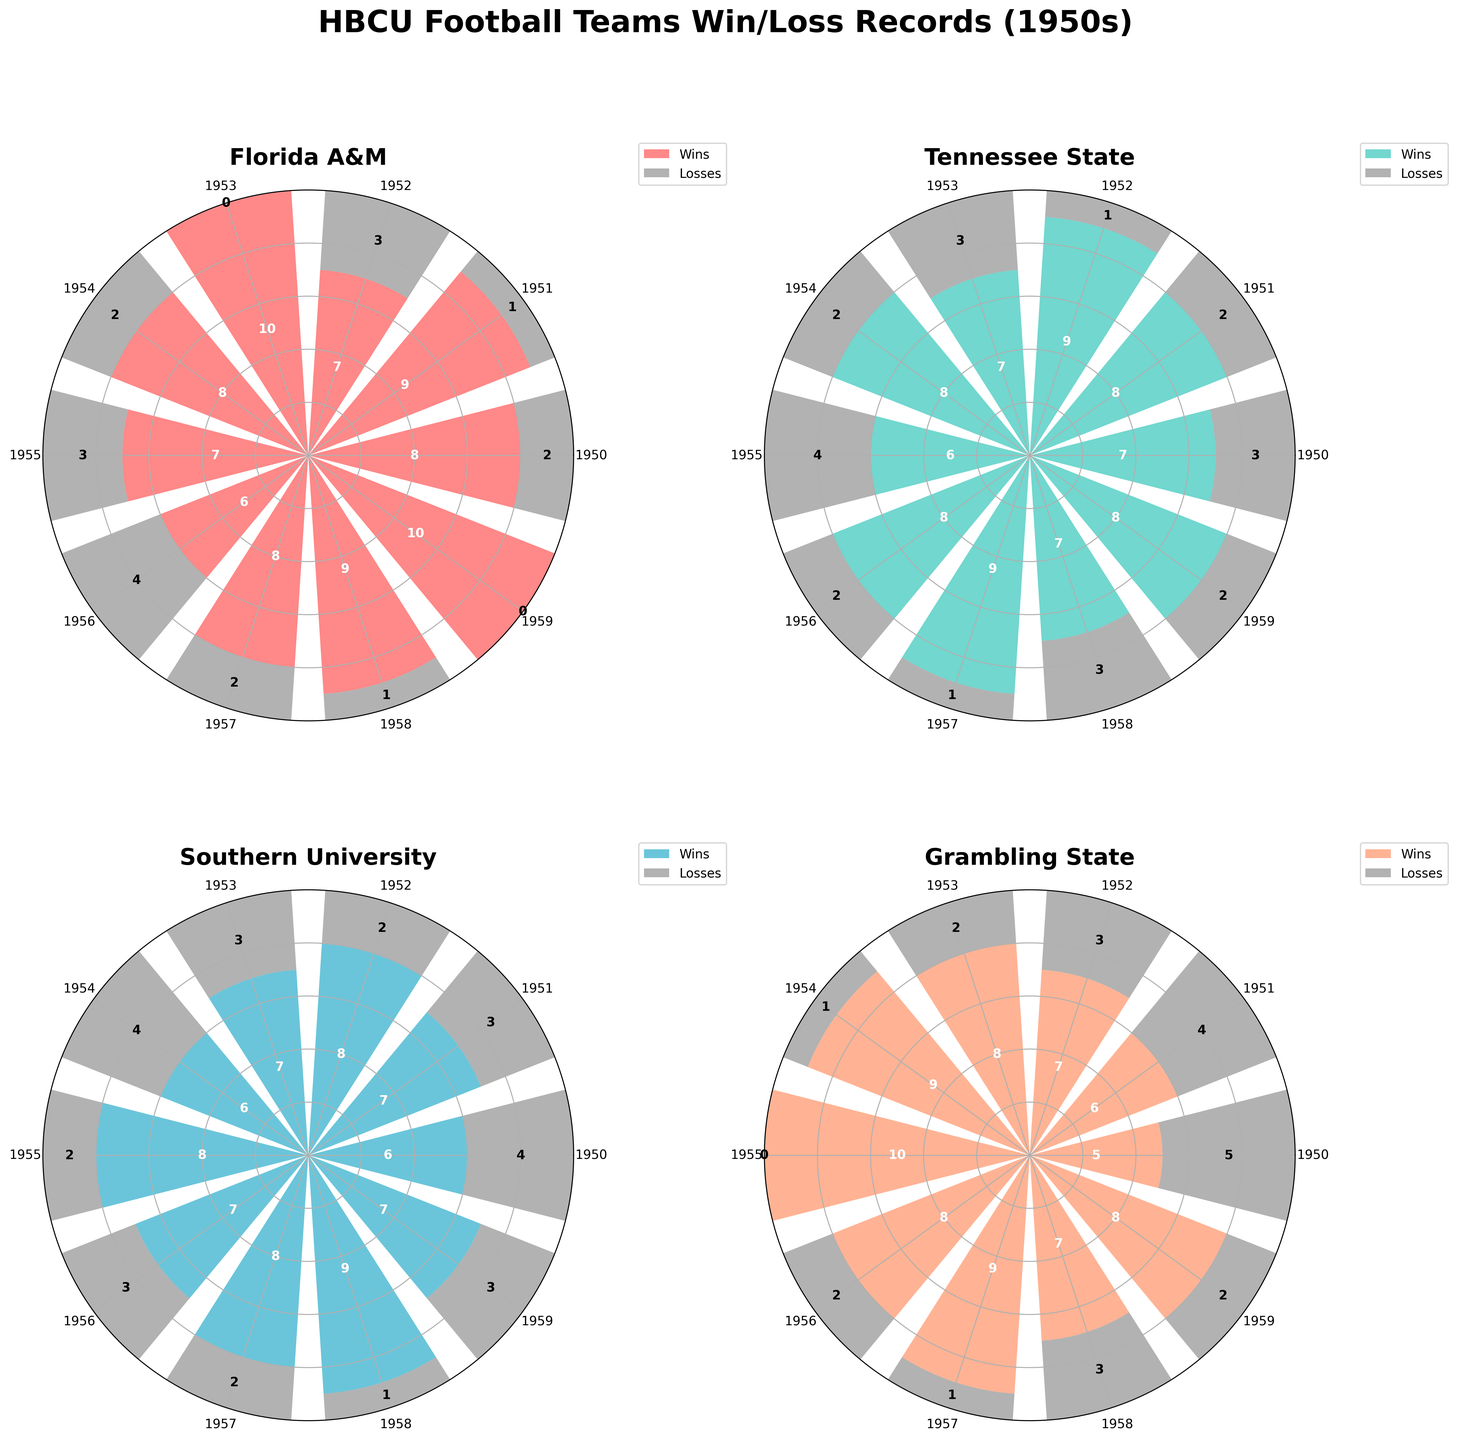What is the highest number of wins achieved by any team in a single year? By looking at the bar heights for wins across all subplots, identify the tallest bar in all subplots. Florida A&M and Grambling State both have a year with 10 wins (1953 and 1955 for Florida A&M, 1955 for Grambling State). Hence, the maximum number of wins in a single year is 10.
Answer: 10 How many total wins did Southern University achieve in the 1950s? Sum the wins from each year for Southern University. The years have the following wins: 6, 7, 8, 7, 6, 8, 7, 8, 9, 7. Summing these numbers: 6 + 7 + 8 + 7 + 6 + 8 + 7 + 8 + 9 + 7 = 73.
Answer: 73 Which team has the most consistent win/loss record over the decade? Consistency can be visually deduced from the uniformity in the heights of the bars over the years. Observing the subplots, Tennessee State appears to have smaller fluctuations in win/loss records compared to the other teams.
Answer: Tennessee State What's the total number of losses for Grambling State over the decade? Sum the losses from each year for Grambling State. The years have the following losses: 5, 4, 3, 2, 1, 0, 2, 1, 3, 2. Summing these numbers: 5 + 4 + 3 + 2 + 1 + 0 + 2 + 1 + 3 + 2 = 23.
Answer: 23 In which year did Florida A&M and Tennessee State both have the highest win records? Check for the year where both Florida A&M and Tennessee State have their highest number of wins. Florida A&M’s highest win count is 10 in 1953 and 1959. Tennessee State's highest win count is 9 in 1952 and 1957. There is no common year where both teams have their highest win records.
Answer: No common year Which team had the most losses in a single year, and what was the number? Look for the tallest bar representing losses across the subplots. Grambling State in 1950 has the highest number of losses, with 5.
Answer: Grambling State, 5 losses Compare Southern University's win/loss record in 1958 with Tennessee State's in the same year. Which team performed better? In 1958, Southern University had 9 wins and 1 loss, while Tennessee State had 7 wins and 3 losses. Therefore, Southern University performed better with more wins and fewer losses.
Answer: Southern University Analyze the trend of Grambling State's win/loss records over the decade. Did they generally improve, decline, or remain stable? Observe the heights of the win/loss bars for Grambling State over the years. Wins seem to increase first, peaking in the mid-1950s, and then there are fluctuations but overall decline in consistency.
Answer: Fluctuate with improvement mid-decade and then variability How often did each team achieve a perfect season (no losses) during the 1950s? Identify the years where the loss bar is zero for each team. Florida A&M achieved it in 1953 and 1959, Grambling State in 1955.
Answer: Florida A&M: 2 times, Grambling State: 1 time 